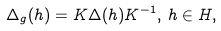Convert formula to latex. <formula><loc_0><loc_0><loc_500><loc_500>\Delta _ { g } ( h ) = K \Delta ( h ) K ^ { - 1 } , \, h \in H ,</formula> 